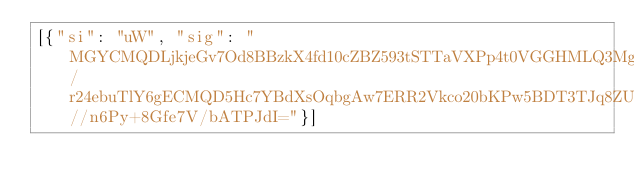<code> <loc_0><loc_0><loc_500><loc_500><_SML_>[{"si": "uW", "sig": "MGYCMQDLjkjeGv7Od8BBzkX4fd10cZBZ593tSTTaVXPp4t0VGGHMLQ3MgB/r24ebuTlY6gECMQD5Hc7YBdXsOqbgAw7ERR2Vkco20bKPw5BDT3TJq8ZUZA//n6Py+8Gfe7V/bATPJdI="}]</code> 